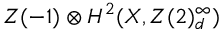Convert formula to latex. <formula><loc_0><loc_0><loc_500><loc_500>Z ( - 1 ) H ^ { 2 } ( X , Z ( 2 ) _ { d } ^ { \infty } )</formula> 